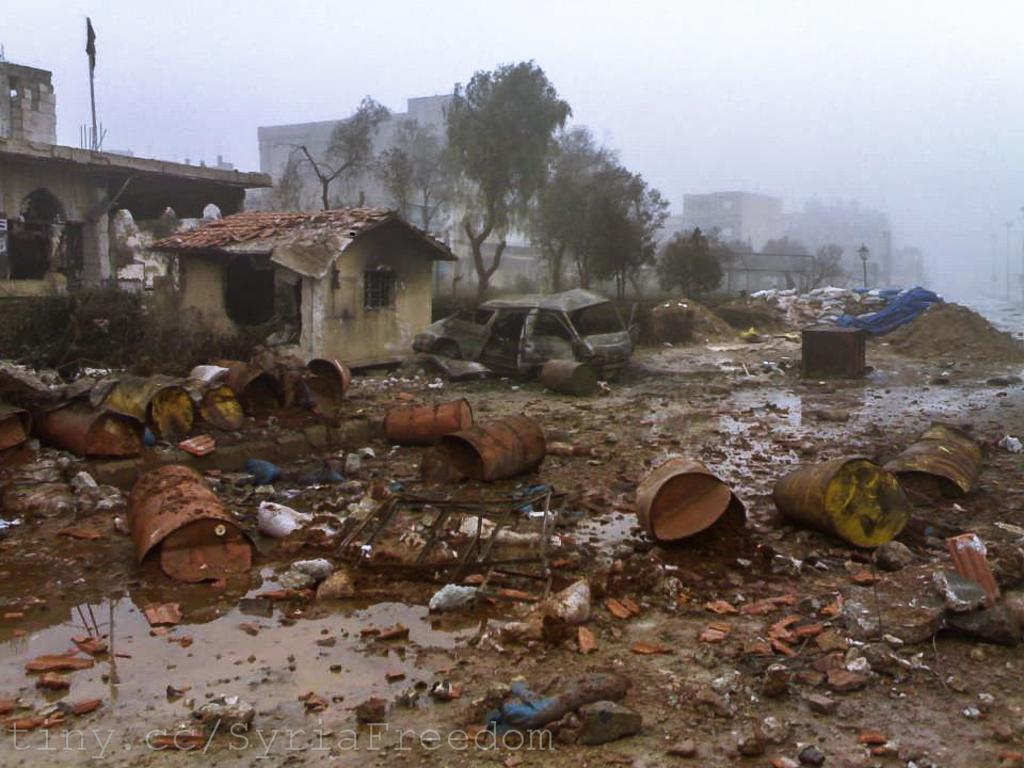What type of structures can be seen in the image? There are buildings in the image. What architectural features can be observed on the buildings? Windows are visible in the image. What type of vegetation is present in the image? There are trees in the image. What type of lighting is present in the image? There are light poles in the image. What mode of transportation is visible in the image? There is a vehicle in the image. What type of terrain is depicted in the image? There is mud in the image. What natural element is present in the image? There is water in the image. What part of the natural environment is visible in the image? The sky is visible in the image. What objects are present on the ground in the image? There are objects on the ground in the image. What type of circle can be seen in the image? There is no circle present in the image. How does the snow affect the buildings in the image? There is no snow present in the image, so it cannot affect the buildings. 